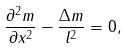Convert formula to latex. <formula><loc_0><loc_0><loc_500><loc_500>\frac { \partial ^ { 2 } m } { \partial x ^ { 2 } } - \frac { \Delta m } { l ^ { 2 } } = 0 ,</formula> 